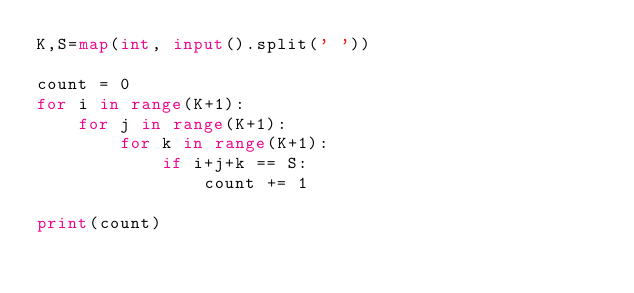<code> <loc_0><loc_0><loc_500><loc_500><_Python_>K,S=map(int, input().split(' '))

count = 0
for i in range(K+1):
    for j in range(K+1):
        for k in range(K+1):
            if i+j+k == S:
                count += 1

print(count)
</code> 